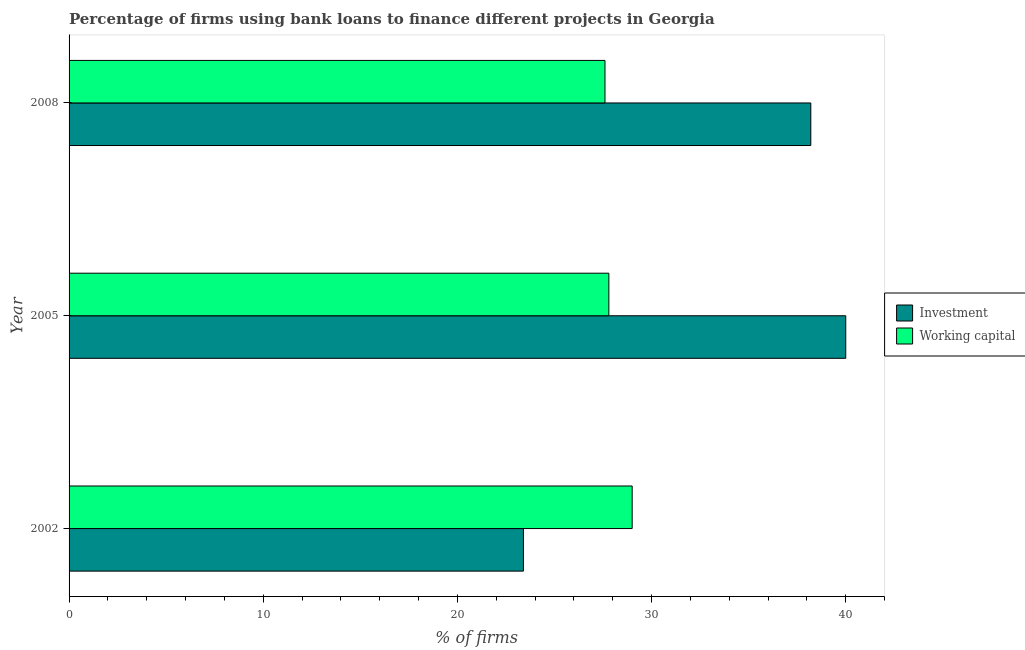How many different coloured bars are there?
Give a very brief answer. 2. How many bars are there on the 3rd tick from the top?
Your answer should be very brief. 2. How many bars are there on the 1st tick from the bottom?
Your answer should be compact. 2. What is the label of the 2nd group of bars from the top?
Provide a succinct answer. 2005. What is the percentage of firms using banks to finance investment in 2008?
Provide a succinct answer. 38.2. Across all years, what is the maximum percentage of firms using banks to finance working capital?
Your answer should be very brief. 29. Across all years, what is the minimum percentage of firms using banks to finance investment?
Your answer should be very brief. 23.4. What is the total percentage of firms using banks to finance investment in the graph?
Provide a short and direct response. 101.6. What is the difference between the percentage of firms using banks to finance working capital in 2005 and the percentage of firms using banks to finance investment in 2008?
Provide a succinct answer. -10.4. What is the average percentage of firms using banks to finance working capital per year?
Give a very brief answer. 28.13. In the year 2005, what is the difference between the percentage of firms using banks to finance working capital and percentage of firms using banks to finance investment?
Ensure brevity in your answer.  -12.2. In how many years, is the percentage of firms using banks to finance investment greater than 20 %?
Your answer should be compact. 3. What is the ratio of the percentage of firms using banks to finance investment in 2002 to that in 2005?
Ensure brevity in your answer.  0.58. Is the difference between the percentage of firms using banks to finance investment in 2005 and 2008 greater than the difference between the percentage of firms using banks to finance working capital in 2005 and 2008?
Provide a short and direct response. Yes. What is the difference between the highest and the second highest percentage of firms using banks to finance investment?
Provide a short and direct response. 1.8. In how many years, is the percentage of firms using banks to finance investment greater than the average percentage of firms using banks to finance investment taken over all years?
Ensure brevity in your answer.  2. What does the 2nd bar from the top in 2008 represents?
Offer a terse response. Investment. What does the 1st bar from the bottom in 2005 represents?
Give a very brief answer. Investment. Does the graph contain any zero values?
Your response must be concise. No. Does the graph contain grids?
Ensure brevity in your answer.  No. Where does the legend appear in the graph?
Give a very brief answer. Center right. What is the title of the graph?
Make the answer very short. Percentage of firms using bank loans to finance different projects in Georgia. Does "Public credit registry" appear as one of the legend labels in the graph?
Offer a terse response. No. What is the label or title of the X-axis?
Provide a short and direct response. % of firms. What is the label or title of the Y-axis?
Provide a succinct answer. Year. What is the % of firms in Investment in 2002?
Ensure brevity in your answer.  23.4. What is the % of firms in Working capital in 2005?
Provide a short and direct response. 27.8. What is the % of firms in Investment in 2008?
Give a very brief answer. 38.2. What is the % of firms of Working capital in 2008?
Your answer should be compact. 27.6. Across all years, what is the maximum % of firms of Investment?
Offer a terse response. 40. Across all years, what is the minimum % of firms in Investment?
Make the answer very short. 23.4. Across all years, what is the minimum % of firms in Working capital?
Provide a short and direct response. 27.6. What is the total % of firms in Investment in the graph?
Provide a succinct answer. 101.6. What is the total % of firms in Working capital in the graph?
Offer a very short reply. 84.4. What is the difference between the % of firms of Investment in 2002 and that in 2005?
Your answer should be very brief. -16.6. What is the difference between the % of firms in Investment in 2002 and that in 2008?
Provide a succinct answer. -14.8. What is the difference between the % of firms in Investment in 2005 and that in 2008?
Your response must be concise. 1.8. What is the difference between the % of firms in Investment in 2002 and the % of firms in Working capital in 2005?
Your answer should be very brief. -4.4. What is the difference between the % of firms of Investment in 2002 and the % of firms of Working capital in 2008?
Keep it short and to the point. -4.2. What is the difference between the % of firms in Investment in 2005 and the % of firms in Working capital in 2008?
Offer a very short reply. 12.4. What is the average % of firms of Investment per year?
Ensure brevity in your answer.  33.87. What is the average % of firms in Working capital per year?
Make the answer very short. 28.13. In the year 2008, what is the difference between the % of firms of Investment and % of firms of Working capital?
Provide a short and direct response. 10.6. What is the ratio of the % of firms of Investment in 2002 to that in 2005?
Provide a succinct answer. 0.58. What is the ratio of the % of firms of Working capital in 2002 to that in 2005?
Offer a very short reply. 1.04. What is the ratio of the % of firms in Investment in 2002 to that in 2008?
Provide a short and direct response. 0.61. What is the ratio of the % of firms in Working capital in 2002 to that in 2008?
Ensure brevity in your answer.  1.05. What is the ratio of the % of firms in Investment in 2005 to that in 2008?
Make the answer very short. 1.05. What is the difference between the highest and the second highest % of firms in Investment?
Provide a succinct answer. 1.8. What is the difference between the highest and the lowest % of firms in Working capital?
Provide a short and direct response. 1.4. 